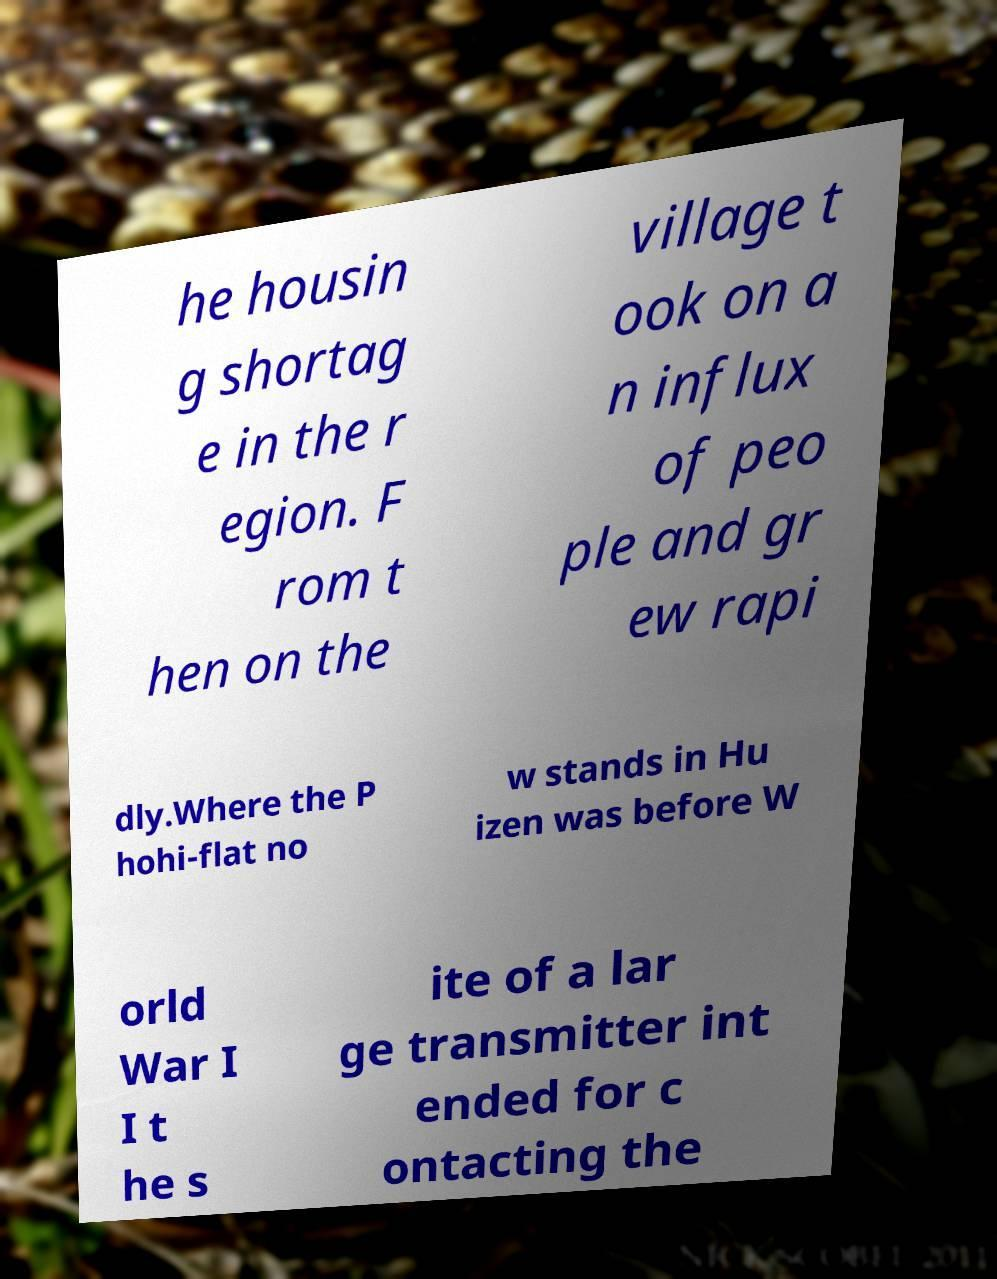Can you read and provide the text displayed in the image?This photo seems to have some interesting text. Can you extract and type it out for me? he housin g shortag e in the r egion. F rom t hen on the village t ook on a n influx of peo ple and gr ew rapi dly.Where the P hohi-flat no w stands in Hu izen was before W orld War I I t he s ite of a lar ge transmitter int ended for c ontacting the 